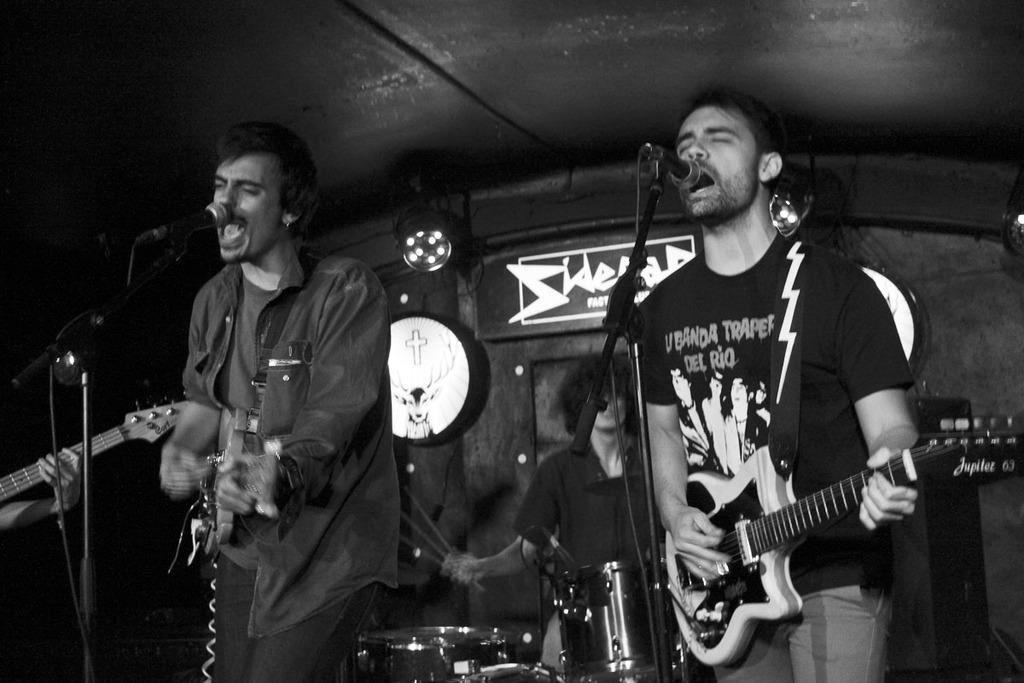What is the color scheme of the image? The image is black and white. How many people are in the image? There are two persons in the image. What are the two persons doing? One person is playing a guitar, and the other person is singing. What are they performing in front of? They are performing in front of a microphone. Which person is playing a musical instrument? The person playing a guitar is playing a musical instrument. What can be seen at the top of the image? There is a focusing light at the top of the image. Can you see any clouds in the image? There are no clouds visible in the image, as it is a black and white image of two people performing in front of a microphone. Is there a banana being used as a musical instrument in the image? No, there is no banana present in the image, and no banana is being used as a musical instrument. 